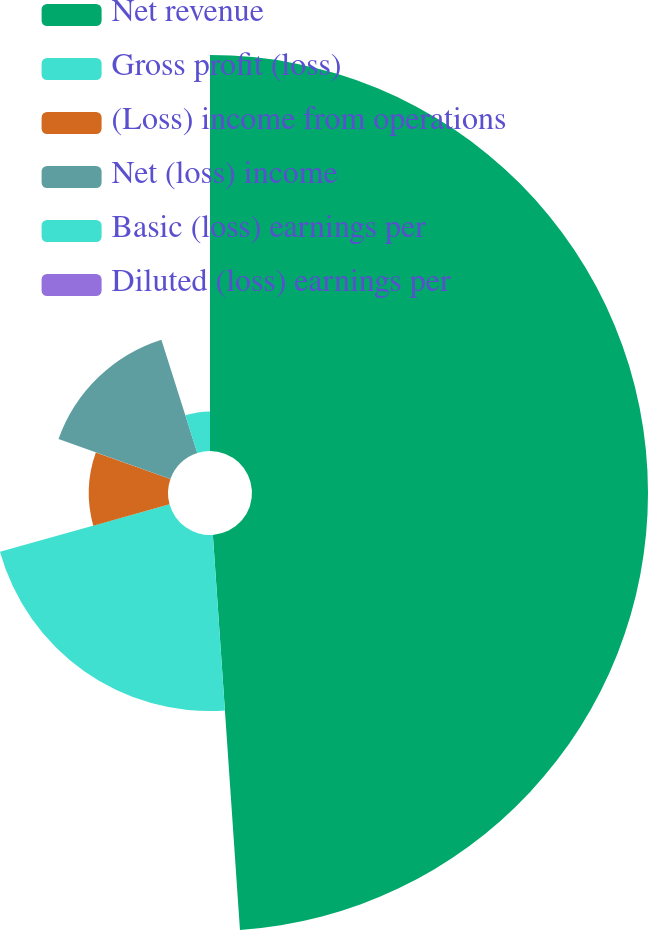<chart> <loc_0><loc_0><loc_500><loc_500><pie_chart><fcel>Net revenue<fcel>Gross profit (loss)<fcel>(Loss) income from operations<fcel>Net (loss) income<fcel>Basic (loss) earnings per<fcel>Diluted (loss) earnings per<nl><fcel>48.91%<fcel>21.75%<fcel>9.78%<fcel>14.67%<fcel>4.89%<fcel>0.0%<nl></chart> 